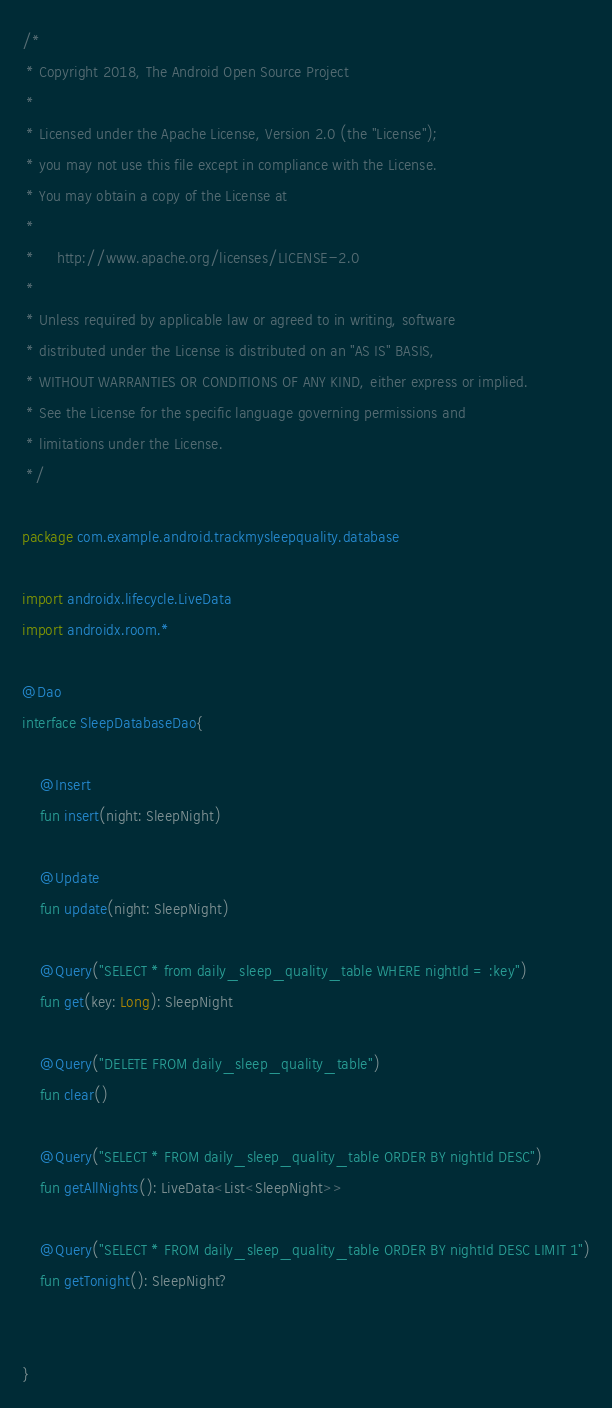<code> <loc_0><loc_0><loc_500><loc_500><_Kotlin_>/*
 * Copyright 2018, The Android Open Source Project
 *
 * Licensed under the Apache License, Version 2.0 (the "License");
 * you may not use this file except in compliance with the License.
 * You may obtain a copy of the License at
 *
 *     http://www.apache.org/licenses/LICENSE-2.0
 *
 * Unless required by applicable law or agreed to in writing, software
 * distributed under the License is distributed on an "AS IS" BASIS,
 * WITHOUT WARRANTIES OR CONDITIONS OF ANY KIND, either express or implied.
 * See the License for the specific language governing permissions and
 * limitations under the License.
 */

package com.example.android.trackmysleepquality.database

import androidx.lifecycle.LiveData
import androidx.room.*

@Dao
interface SleepDatabaseDao{

    @Insert
    fun insert(night: SleepNight)

    @Update
    fun update(night: SleepNight)

    @Query("SELECT * from daily_sleep_quality_table WHERE nightId = :key")
    fun get(key: Long): SleepNight

    @Query("DELETE FROM daily_sleep_quality_table")
    fun clear()

    @Query("SELECT * FROM daily_sleep_quality_table ORDER BY nightId DESC")
    fun getAllNights(): LiveData<List<SleepNight>>

    @Query("SELECT * FROM daily_sleep_quality_table ORDER BY nightId DESC LIMIT 1")
    fun getTonight(): SleepNight?


}
</code> 